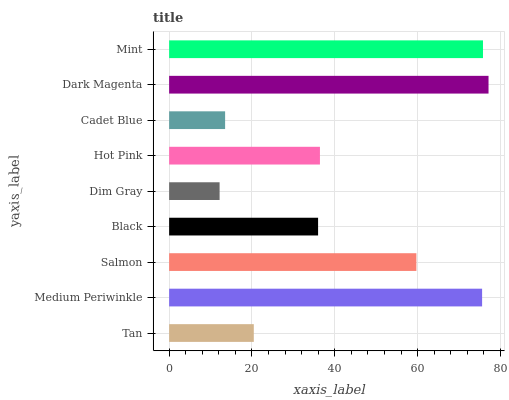Is Dim Gray the minimum?
Answer yes or no. Yes. Is Dark Magenta the maximum?
Answer yes or no. Yes. Is Medium Periwinkle the minimum?
Answer yes or no. No. Is Medium Periwinkle the maximum?
Answer yes or no. No. Is Medium Periwinkle greater than Tan?
Answer yes or no. Yes. Is Tan less than Medium Periwinkle?
Answer yes or no. Yes. Is Tan greater than Medium Periwinkle?
Answer yes or no. No. Is Medium Periwinkle less than Tan?
Answer yes or no. No. Is Hot Pink the high median?
Answer yes or no. Yes. Is Hot Pink the low median?
Answer yes or no. Yes. Is Mint the high median?
Answer yes or no. No. Is Dark Magenta the low median?
Answer yes or no. No. 